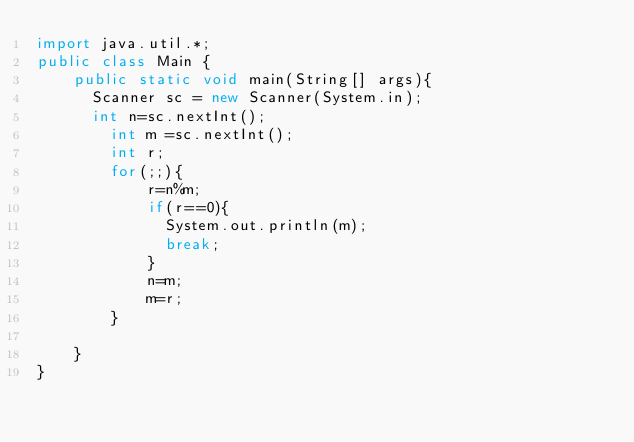<code> <loc_0><loc_0><loc_500><loc_500><_Java_>import java.util.*;
public class Main {
    public static void main(String[] args){
    	Scanner sc = new Scanner(System.in);
    	int n=sc.nextInt();
        int m =sc.nextInt();
        int r;
        for(;;){
            r=n%m;
            if(r==0){
            	System.out.println(m);
            	break;
            }
            n=m;
            m=r;
        }

    }
}
</code> 